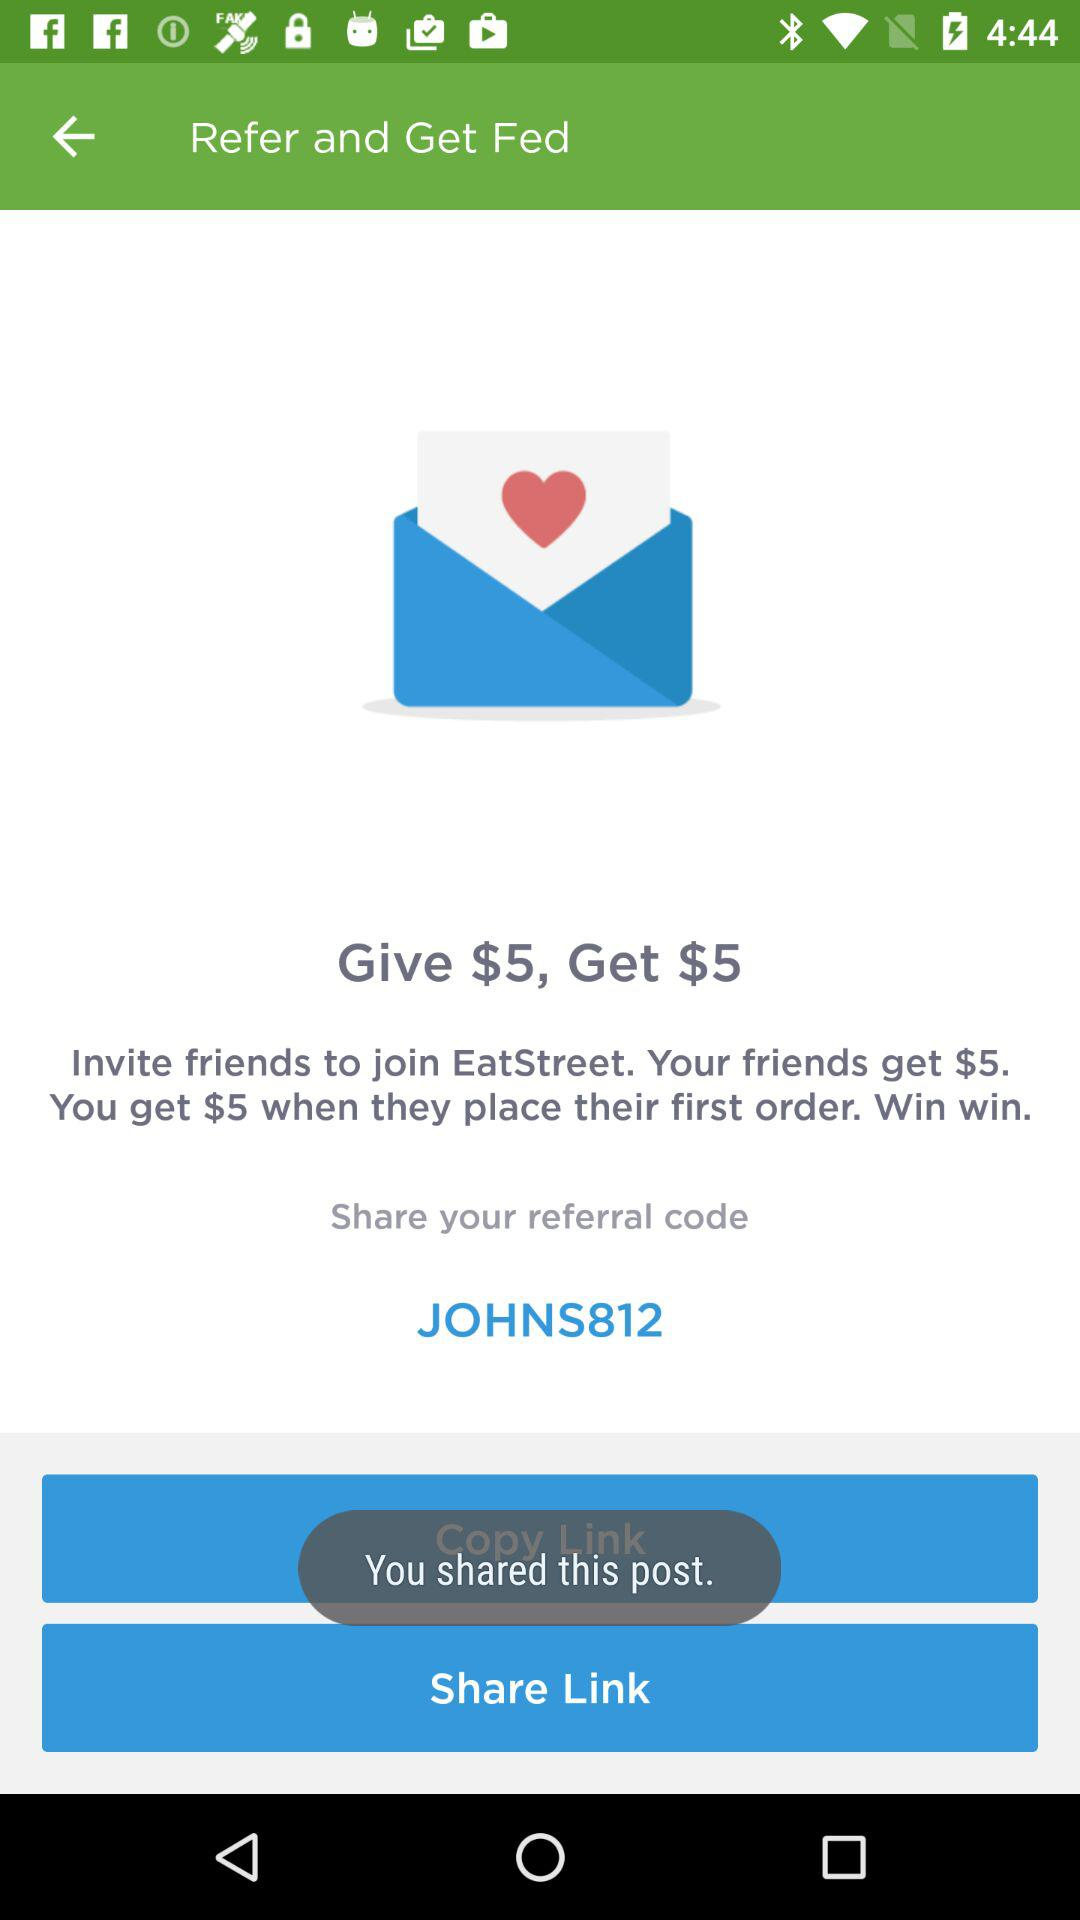How much can you earn by inviting friends? You can earn $5 on their first order. 